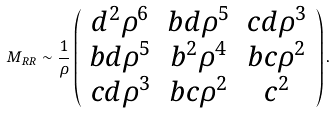Convert formula to latex. <formula><loc_0><loc_0><loc_500><loc_500>M _ { R R } \sim \frac { 1 } { \rho } \left ( \begin{array} { c c c } d ^ { 2 } \rho ^ { 6 } & b d \rho ^ { 5 } & c d \rho ^ { 3 } \\ b d \rho ^ { 5 } & b ^ { 2 } \rho ^ { 4 } & b c \rho ^ { 2 } \\ c d \rho ^ { 3 } & b c \rho ^ { 2 } & c ^ { 2 } \end{array} \right ) .</formula> 